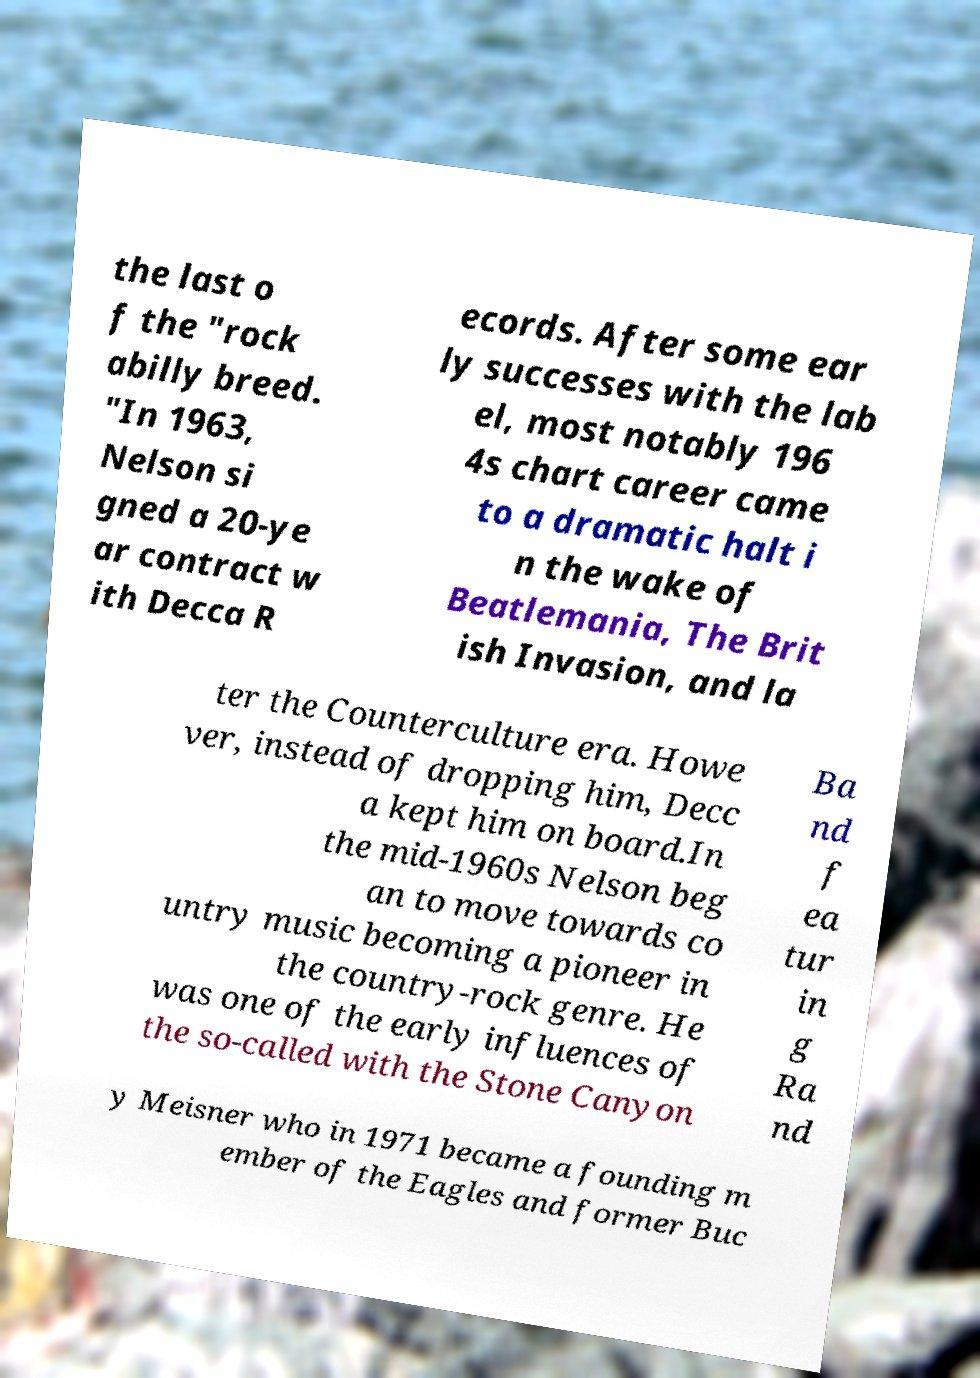What messages or text are displayed in this image? I need them in a readable, typed format. the last o f the "rock abilly breed. "In 1963, Nelson si gned a 20-ye ar contract w ith Decca R ecords. After some ear ly successes with the lab el, most notably 196 4s chart career came to a dramatic halt i n the wake of Beatlemania, The Brit ish Invasion, and la ter the Counterculture era. Howe ver, instead of dropping him, Decc a kept him on board.In the mid-1960s Nelson beg an to move towards co untry music becoming a pioneer in the country-rock genre. He was one of the early influences of the so-called with the Stone Canyon Ba nd f ea tur in g Ra nd y Meisner who in 1971 became a founding m ember of the Eagles and former Buc 